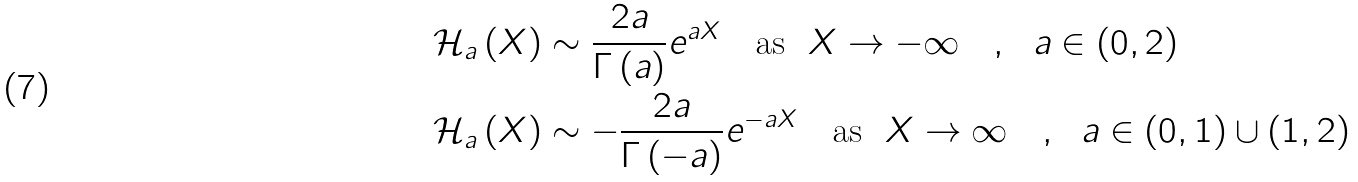<formula> <loc_0><loc_0><loc_500><loc_500>\mathcal { H } _ { a } \left ( X \right ) & \sim \frac { 2 a } { \Gamma \left ( a \right ) } e ^ { a X } \quad \text {as\ \ } X \rightarrow - \infty \quad , \ \ a \in \left ( 0 , 2 \right ) \\ \mathcal { H } _ { a } \left ( X \right ) & \sim - \frac { 2 a } { \Gamma \left ( - a \right ) } e ^ { - a X } \quad \text {as\ \ } X \rightarrow \infty \quad , \ \ a \in \left ( 0 , 1 \right ) \cup \left ( 1 , 2 \right )</formula> 